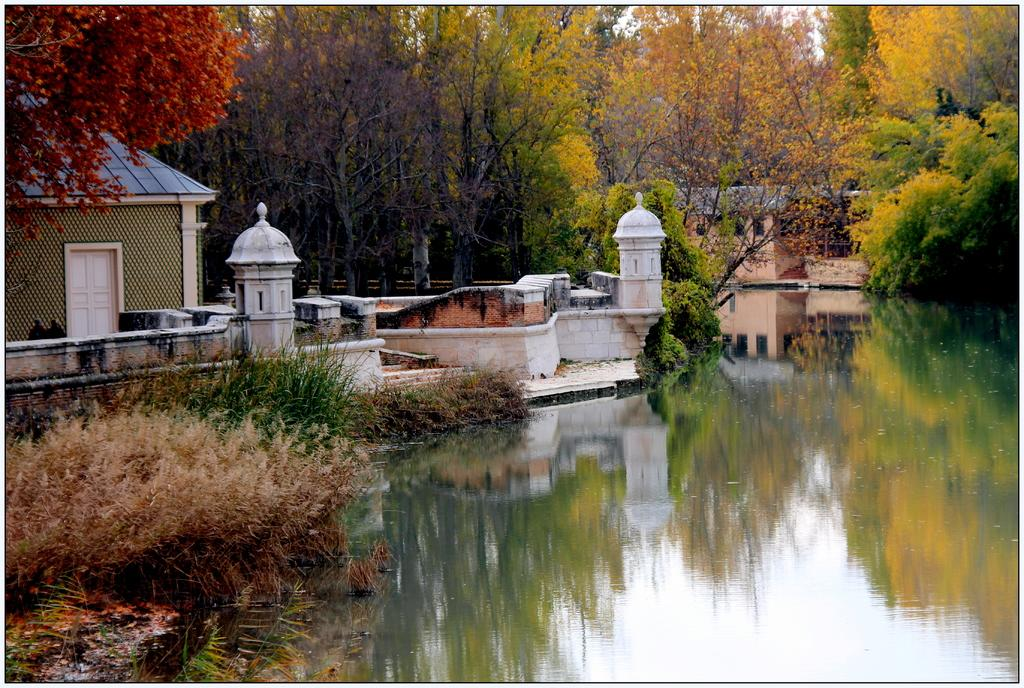What type of natural environment is visible in the image? Water and grass are visible in the image, suggesting a natural setting. What type of man-made structures can be seen in the image? There are buildings in the image. What other natural elements are present in the image? There are trees in the image. What page of the guide does the image appear on? The image is not part of a guide, so there is no page number associated with it. 